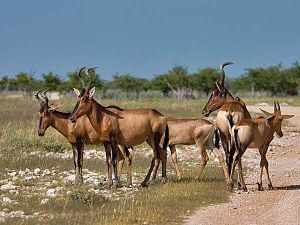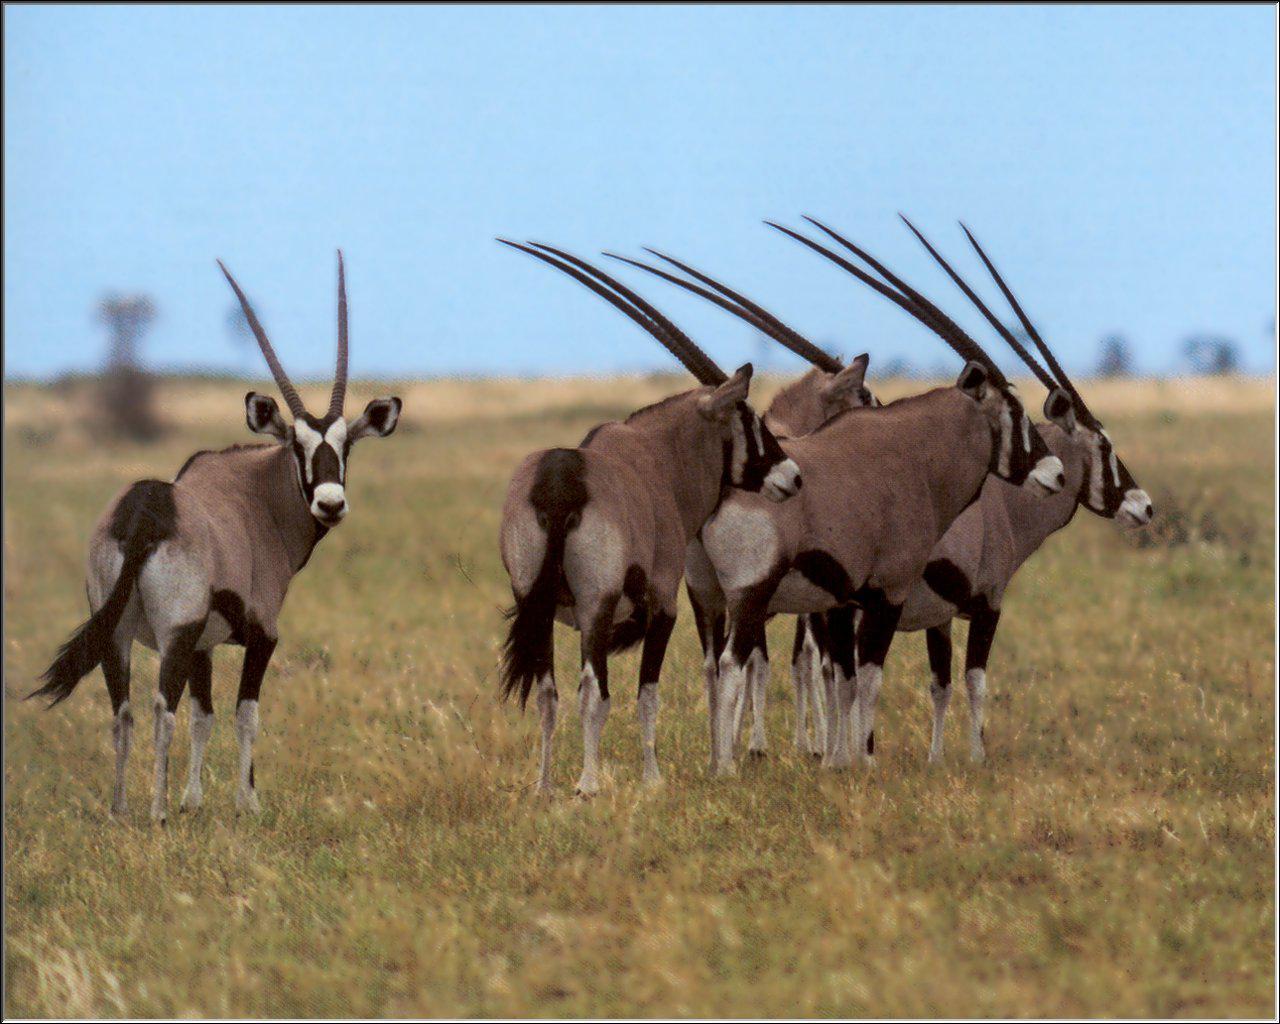The first image is the image on the left, the second image is the image on the right. Given the left and right images, does the statement "Only two antelope-type animals are shown, in total." hold true? Answer yes or no. No. 